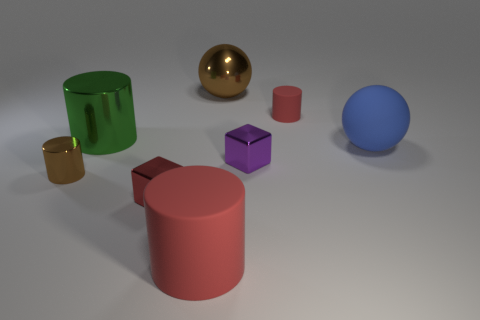What is the lighting like in this scene? The lighting in the scene seems to come from a single source above the objects, casting soft shadows onto the surface. The main light source creates a gentle highlight on the objects, emphasizing their textures and colors, and contributing to the overall calm and composed atmosphere of the scene. 